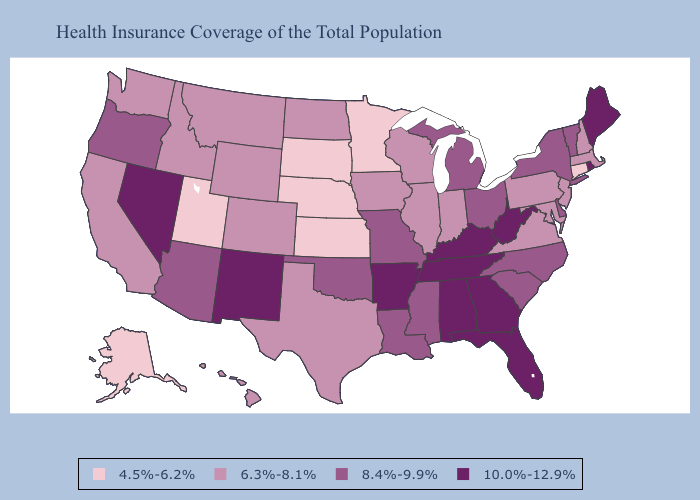What is the highest value in the USA?
Write a very short answer. 10.0%-12.9%. What is the lowest value in states that border North Dakota?
Answer briefly. 4.5%-6.2%. Name the states that have a value in the range 10.0%-12.9%?
Give a very brief answer. Alabama, Arkansas, Florida, Georgia, Kentucky, Maine, Nevada, New Mexico, Rhode Island, Tennessee, West Virginia. Name the states that have a value in the range 8.4%-9.9%?
Quick response, please. Arizona, Delaware, Louisiana, Michigan, Mississippi, Missouri, New York, North Carolina, Ohio, Oklahoma, Oregon, South Carolina, Vermont. What is the value of Colorado?
Write a very short answer. 6.3%-8.1%. Which states have the lowest value in the USA?
Short answer required. Alaska, Connecticut, Kansas, Minnesota, Nebraska, South Dakota, Utah. What is the value of New Mexico?
Write a very short answer. 10.0%-12.9%. Does Pennsylvania have a higher value than Maine?
Write a very short answer. No. What is the value of Washington?
Give a very brief answer. 6.3%-8.1%. Name the states that have a value in the range 8.4%-9.9%?
Concise answer only. Arizona, Delaware, Louisiana, Michigan, Mississippi, Missouri, New York, North Carolina, Ohio, Oklahoma, Oregon, South Carolina, Vermont. What is the value of West Virginia?
Give a very brief answer. 10.0%-12.9%. Which states have the lowest value in the MidWest?
Concise answer only. Kansas, Minnesota, Nebraska, South Dakota. Name the states that have a value in the range 10.0%-12.9%?
Short answer required. Alabama, Arkansas, Florida, Georgia, Kentucky, Maine, Nevada, New Mexico, Rhode Island, Tennessee, West Virginia. Which states have the lowest value in the USA?
Be succinct. Alaska, Connecticut, Kansas, Minnesota, Nebraska, South Dakota, Utah. Which states have the lowest value in the USA?
Be succinct. Alaska, Connecticut, Kansas, Minnesota, Nebraska, South Dakota, Utah. 